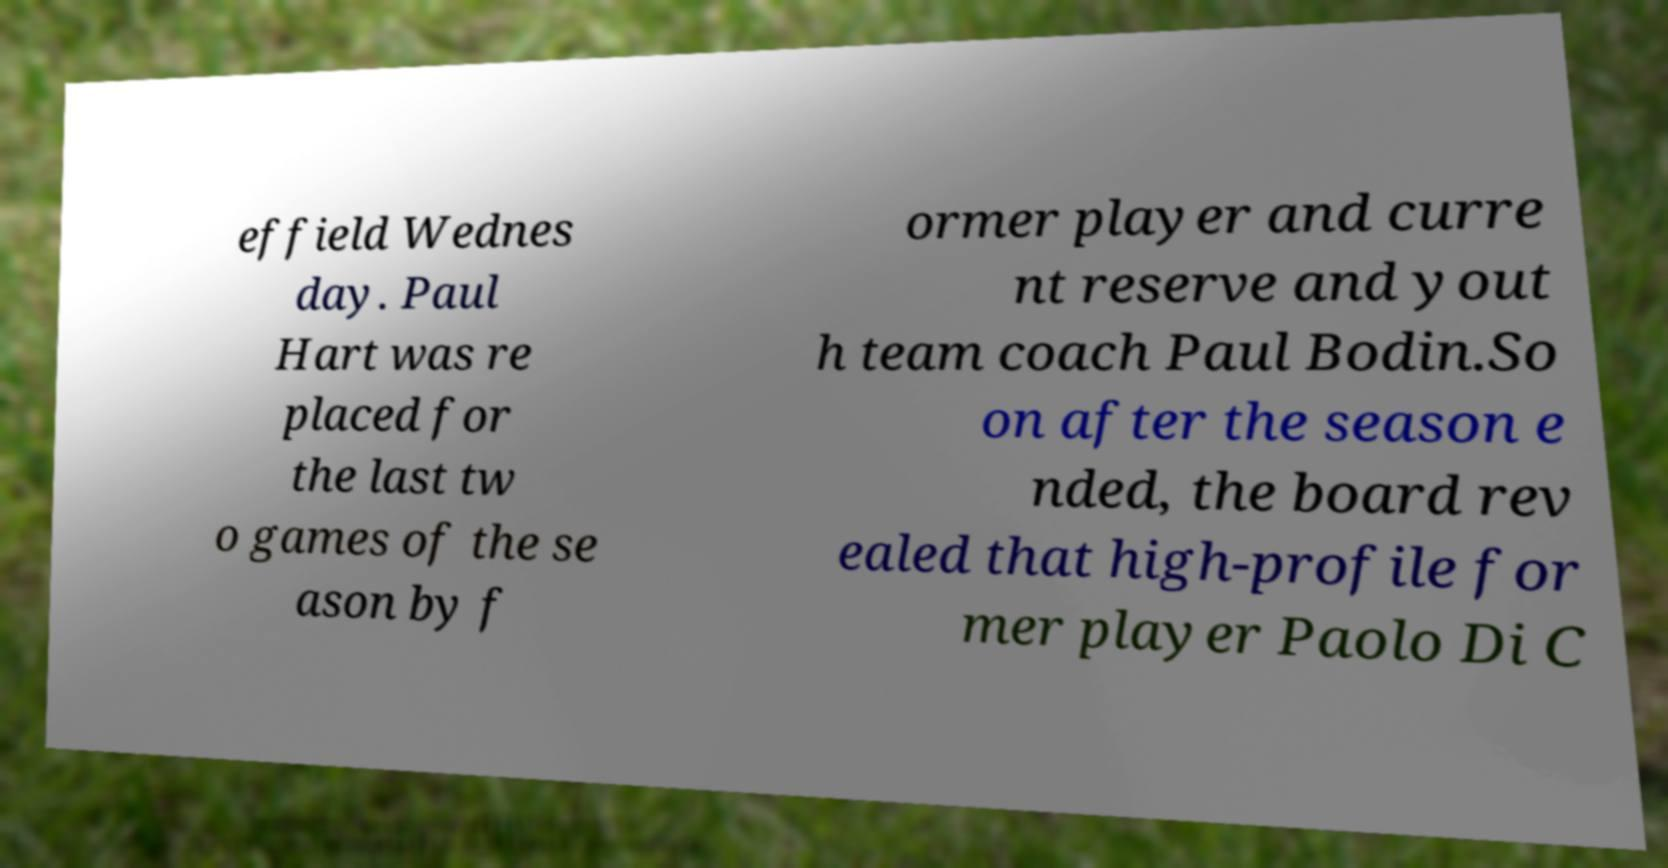Could you assist in decoding the text presented in this image and type it out clearly? effield Wednes day. Paul Hart was re placed for the last tw o games of the se ason by f ormer player and curre nt reserve and yout h team coach Paul Bodin.So on after the season e nded, the board rev ealed that high-profile for mer player Paolo Di C 